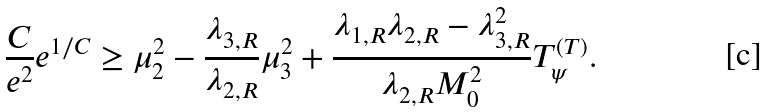Convert formula to latex. <formula><loc_0><loc_0><loc_500><loc_500>\frac { C } { e ^ { 2 } } e ^ { 1 / C } \geq \mu _ { 2 } ^ { 2 } - \frac { \lambda _ { 3 , R } } { \lambda _ { 2 , R } } \mu _ { 3 } ^ { 2 } + \frac { \lambda _ { 1 , R } \lambda _ { 2 , R } - \lambda _ { 3 , R } ^ { 2 } } { \lambda _ { 2 , R } M _ { 0 } ^ { 2 } } T _ { \psi } ^ { ( T ) } .</formula> 